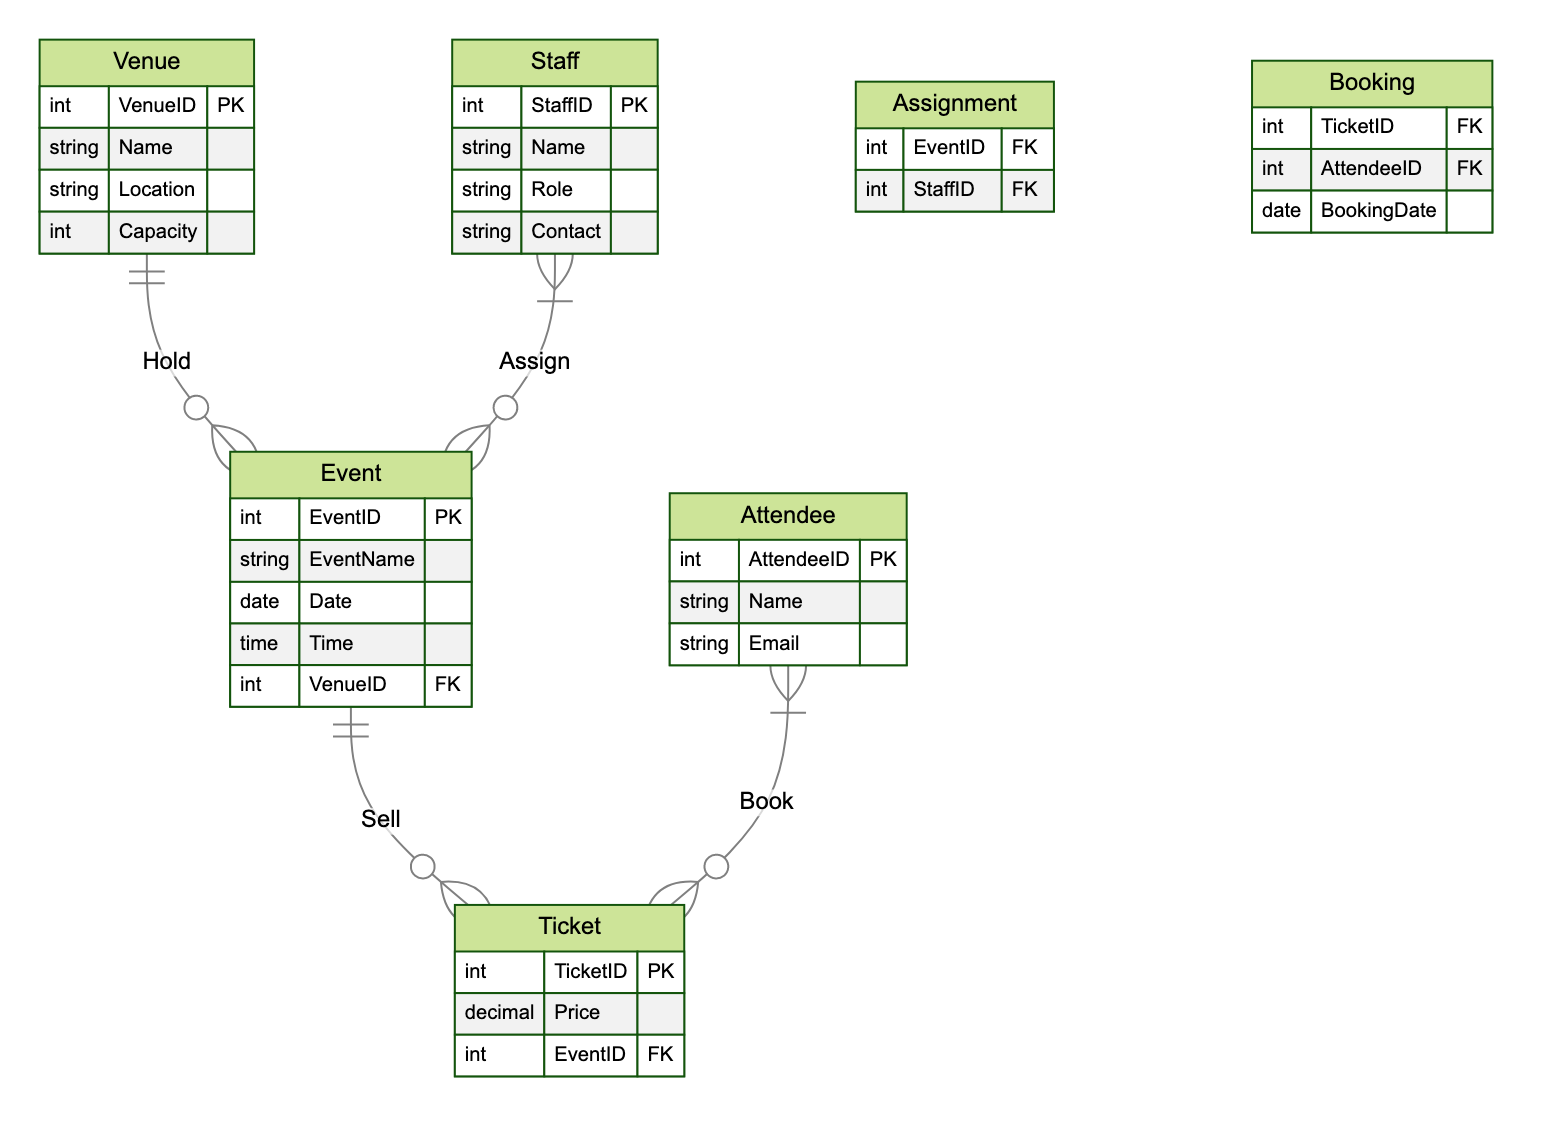What is the maximum capacity of a venue? The "Venue" entity in the diagram has an attribute named "Capacity." By examining this attribute, we conclude that it specifies the maximum number of attendees that a venue can accommodate. Therefore, the answer reflects the value of this attribute as defined in the diagram.
Answer: Capacity How many relationships involve the "Staff" entity? The "Staff" entity is involved in two relationships in the diagram: one for "Assign" with the "Event" entity and another with the joining entity "Assignment." Therefore, we count these two relationships to answer the question.
Answer: 2 What is the role of the "Attendee" in the diagram? The "Attendee" entity is connected to the "Ticket" entity through the "Book" relationship, indicating that attendees purchase tickets for events. Thus, we determine that the primary role of the "Attendee" is to book tickets.
Answer: Book tickets Which entity holds the relationship "Sell"? The "Sell" relationship is established between the "Event" and "Ticket" entities. The diagram shows that the "Event" entity is selling tickets for each specific event. Therefore, we identify the entity that holds this relationship.
Answer: Event What does the "Booking" entity represent in the diagram? The "Booking" entity serves as a joining entity for the many-to-many relationship between "Attendee" and "Ticket." It records the combinations of attendees and the tickets they have booked. Thus, we can summarize its role as recording ticket bookings.
Answer: Ticket bookings What is the foreign key in the "Event" entity? The diagram indicates that the "Event" entity contains a foreign key named "VenueID," which references the "Venue" entity to indicate the hosting venue for that event. Therefore, we identify this attribute based on its function.
Answer: VenueID How many tickets can be associated with a single event? According to the diagram, the "Event" entity has a one-to-many relationship with the "Ticket" entity, meaning that each event can have multiple tickets associated with it. Thus, we conclude that there is no set limit, so the answer reflects the nature of the relationship.
Answer: Many What is the purpose of the "Assignment" entity? The "Assignment" entity acts as a joining entity that connects the "Staff" and "Event" entities, reflecting which staff members are assigned to which events. This relationship features a many-to-many nature, indicating its purpose in managing staff assignments for events.
Answer: Staff assignments Which attribute defines the venue's location? In the "Venue" entity, there is an attribute explicitly named "Location." This attribute provides essential information by defining where the venue is situated. Therefore, we directly refer to this attribute to answer the question.
Answer: Location 